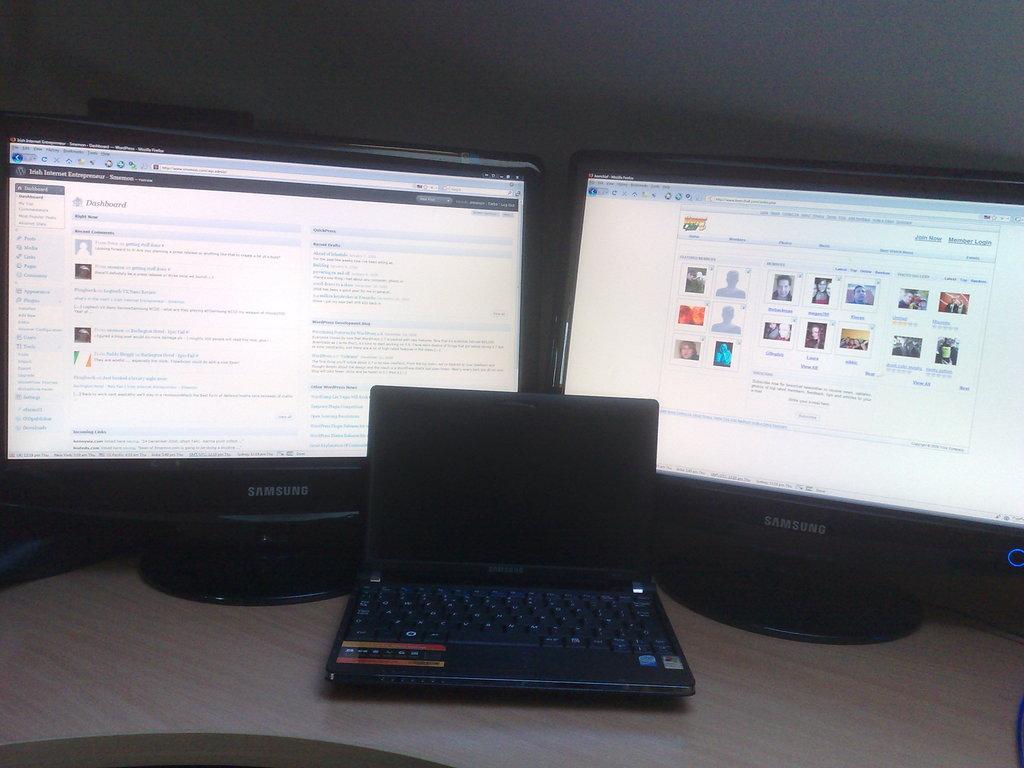What kind of monitors are these?
Give a very brief answer. Samsung. Is the screen on the left a dashboard?
Provide a succinct answer. Yes. 